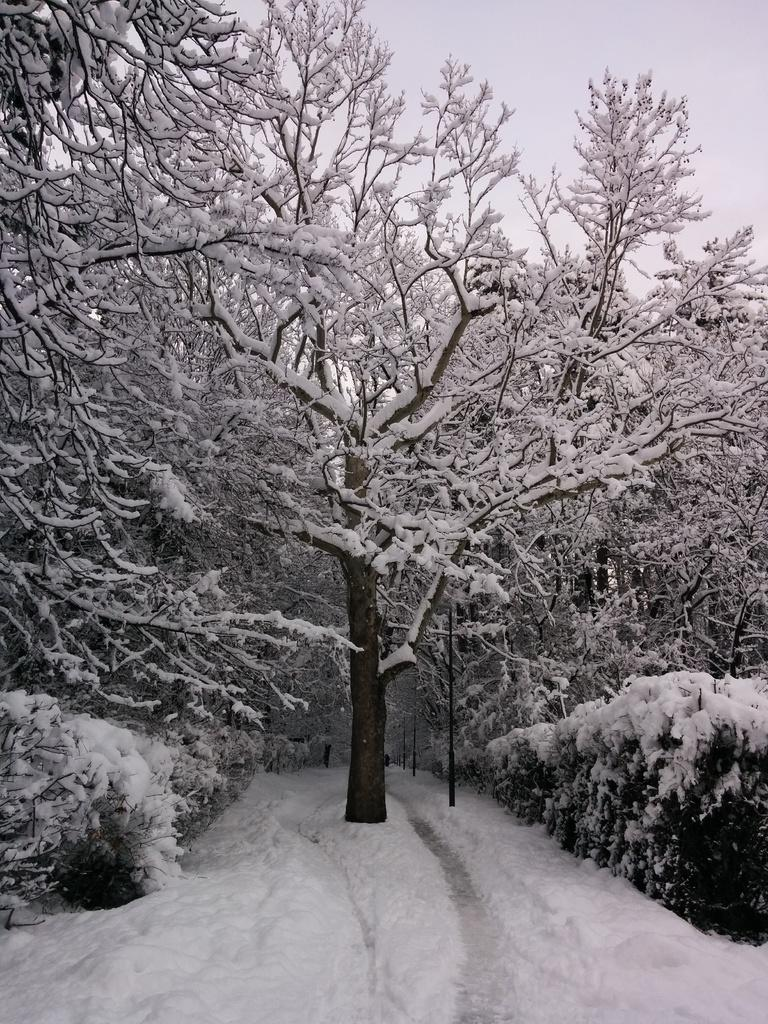What type of vegetation can be seen in the image? There are shrubs and trees in the image. What is the weather like in the image? There is snow visible in the image, indicating a cold or wintery environment. What is the starting point of the hiking trail in the image? There is no hiking trail or starting point visible in the image; it only features shrubs, trees, and snow. 